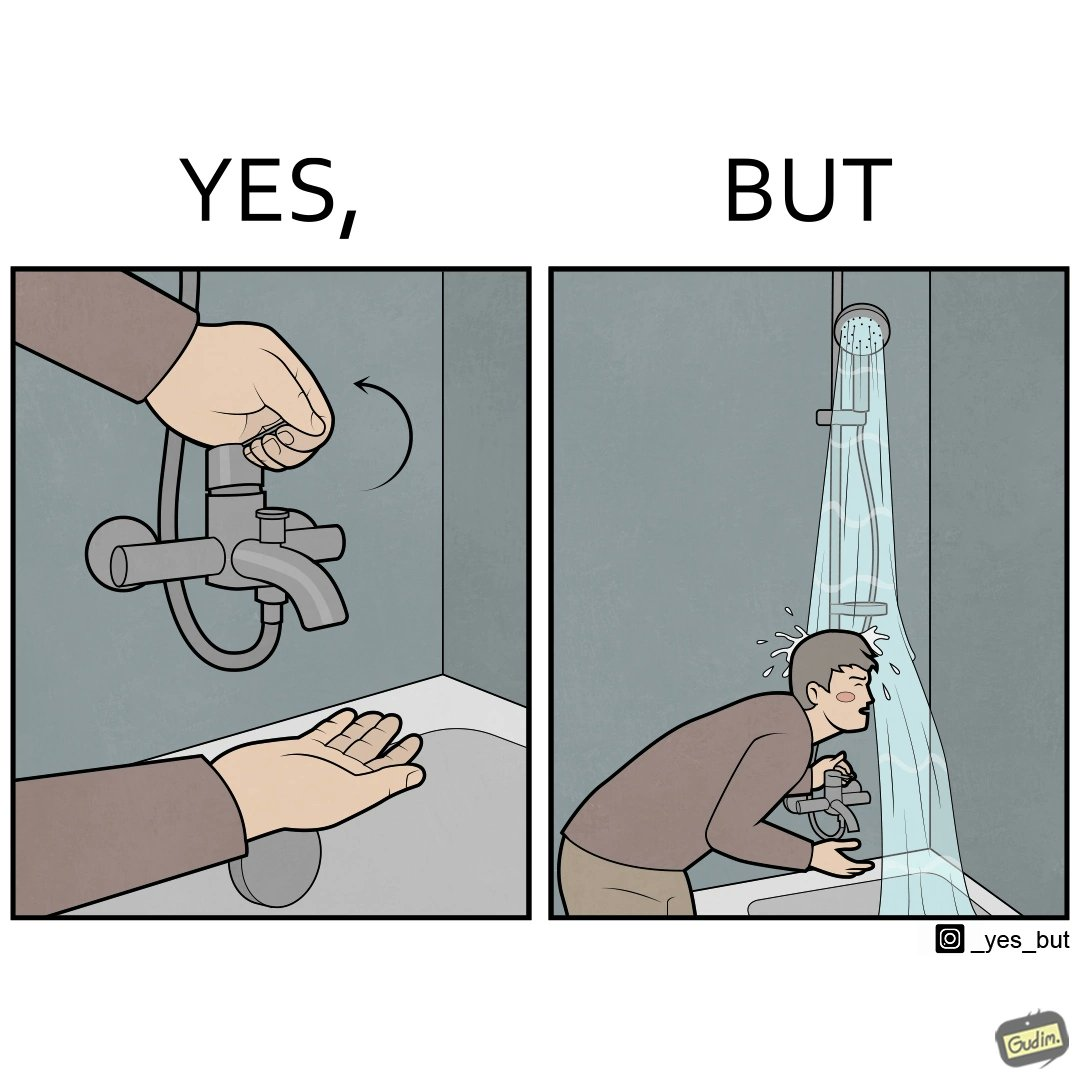Is this image satirical or non-satirical? Yes, this image is satirical. 